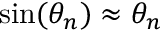Convert formula to latex. <formula><loc_0><loc_0><loc_500><loc_500>\sin ( \theta _ { n } ) \approx \theta _ { n }</formula> 